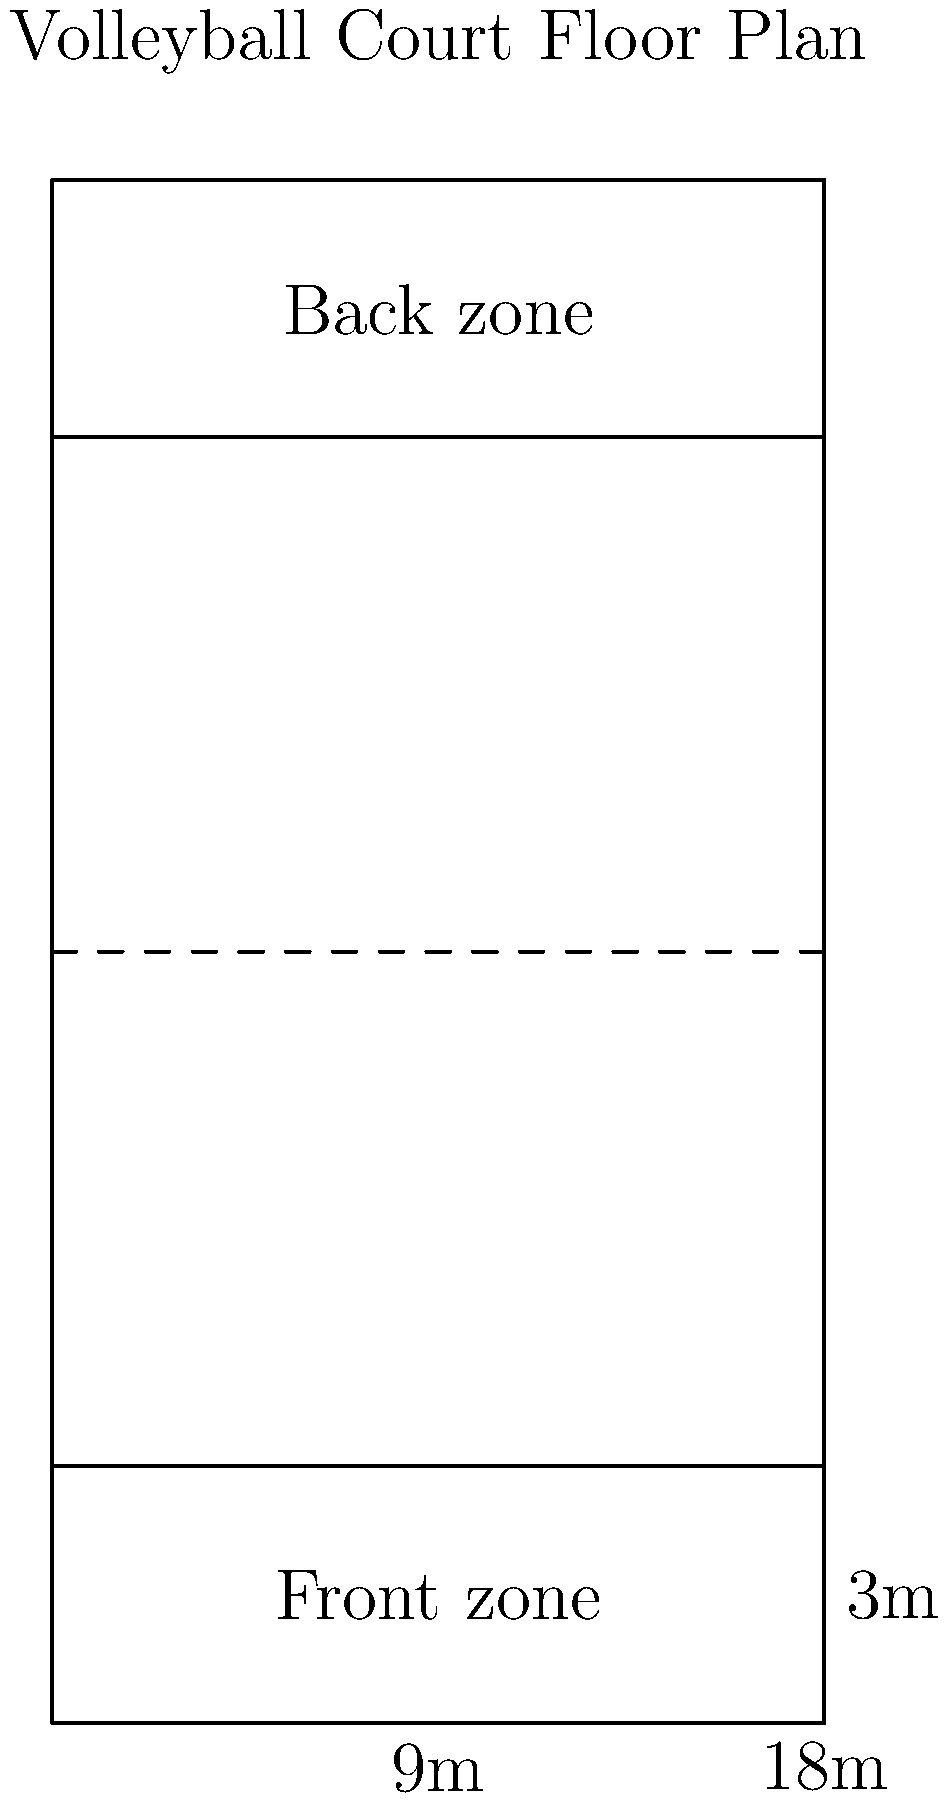Based on the volleyball court floor plan provided, calculate the total area of the two front zones (attack zones) combined. Express your answer in square meters. To calculate the total area of the two front zones, we'll follow these steps:

1. Identify the dimensions of a single front zone:
   - Width of the court: 9 meters
   - Depth of the front zone: 3 meters (distance from the net to the attack line)

2. Calculate the area of a single front zone:
   Area = Width × Depth
   Area = 9 m × 3 m = 27 m²

3. Since there are two identical front zones (one on each side of the net), we need to multiply the area of one front zone by 2:
   Total front zone area = 2 × 27 m² = 54 m²

Therefore, the total area of the two front zones combined is 54 square meters.
Answer: 54 m² 